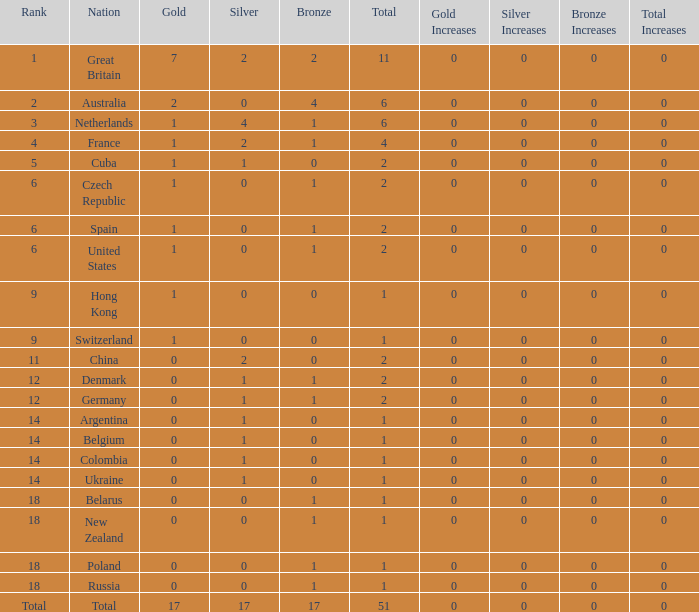Tell me the rank for bronze less than 17 and gold less than 1 11.0. 